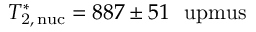Convert formula to latex. <formula><loc_0><loc_0><loc_500><loc_500>T _ { 2 , \, n u c } ^ { \ast } = 8 8 7 \pm 5 1 \ u p m u s</formula> 